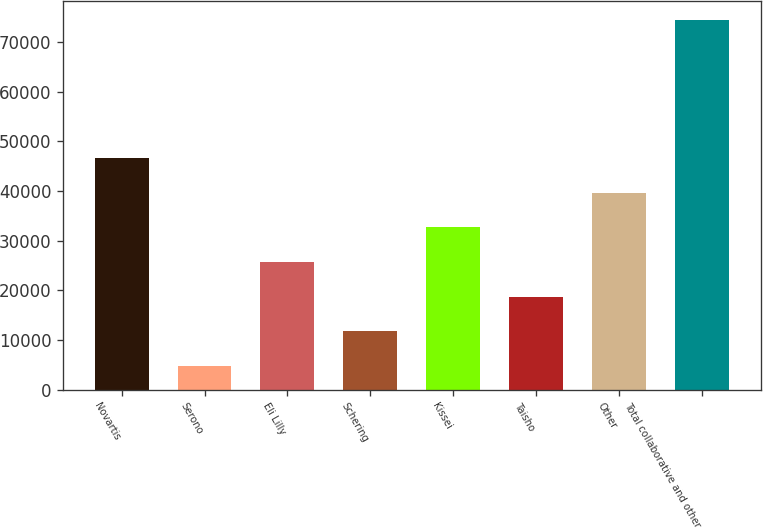<chart> <loc_0><loc_0><loc_500><loc_500><bar_chart><fcel>Novartis<fcel>Serono<fcel>Eli Lilly<fcel>Schering<fcel>Kissei<fcel>Taisho<fcel>Other<fcel>Total collaborative and other<nl><fcel>46629.2<fcel>4802<fcel>25715.6<fcel>11773.2<fcel>32686.8<fcel>18744.4<fcel>39658<fcel>74514<nl></chart> 